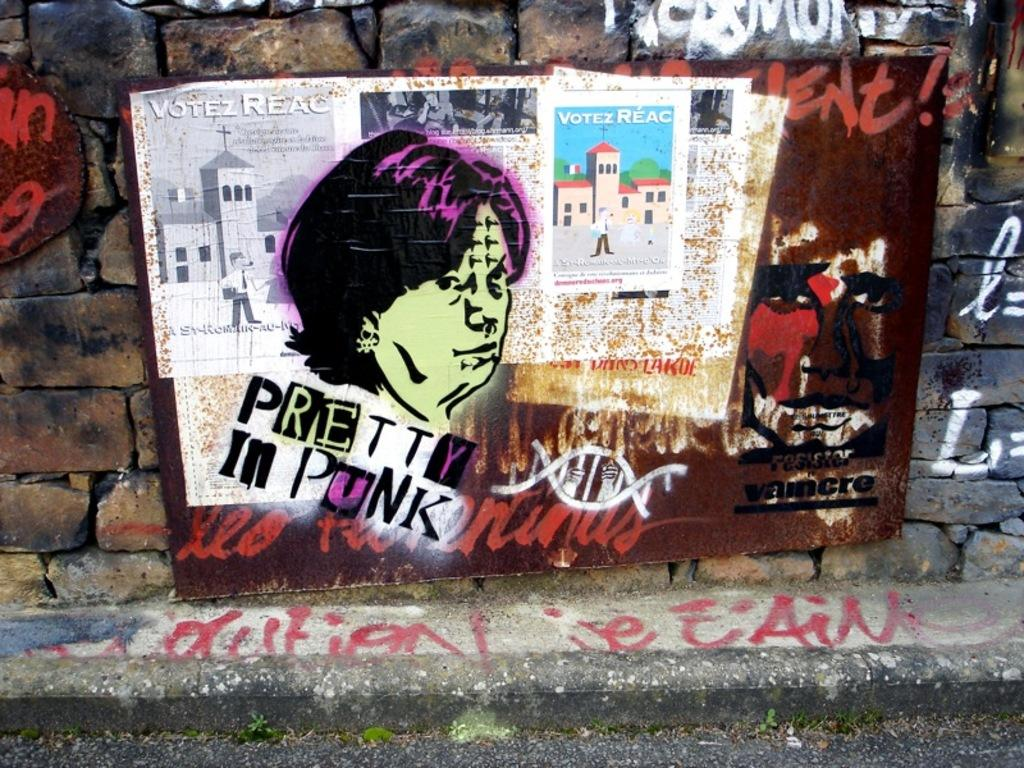<image>
Relay a brief, clear account of the picture shown. Artist graffiti on a wall that features the work of pretty in punk. 